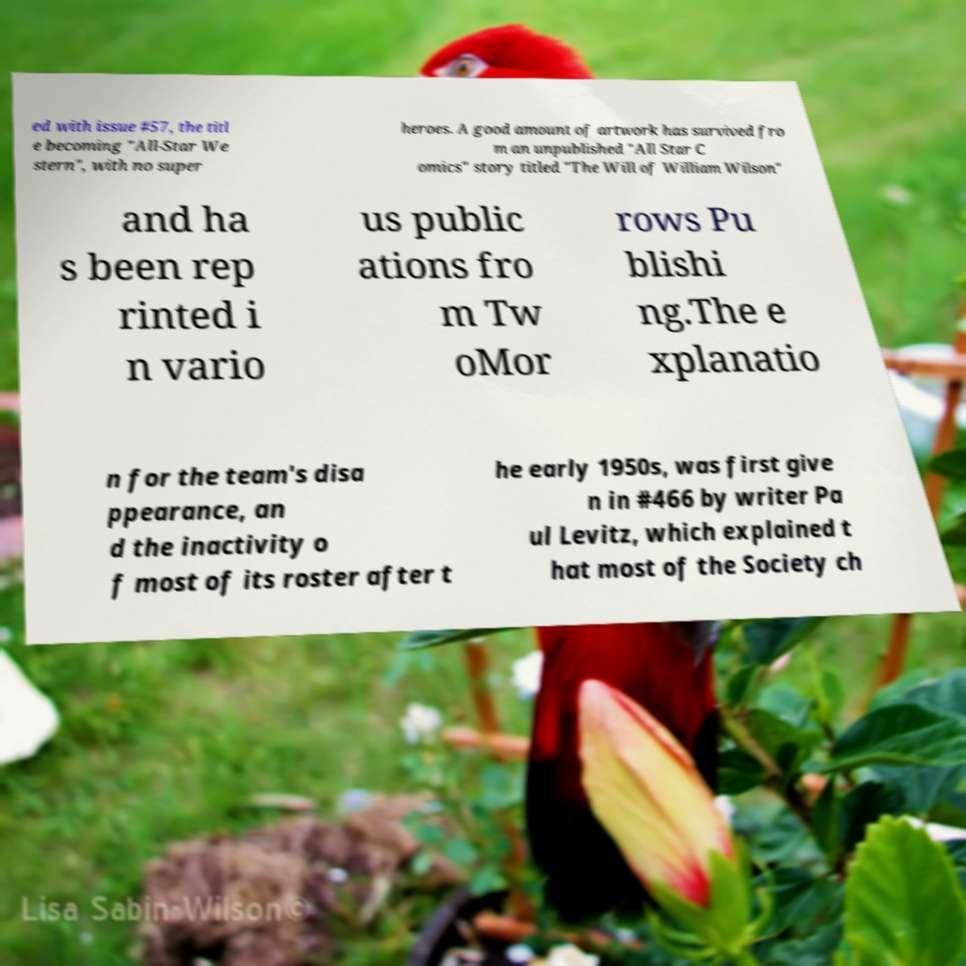There's text embedded in this image that I need extracted. Can you transcribe it verbatim? ed with issue #57, the titl e becoming "All-Star We stern", with no super heroes. A good amount of artwork has survived fro m an unpublished "All Star C omics" story titled "The Will of William Wilson" and ha s been rep rinted i n vario us public ations fro m Tw oMor rows Pu blishi ng.The e xplanatio n for the team's disa ppearance, an d the inactivity o f most of its roster after t he early 1950s, was first give n in #466 by writer Pa ul Levitz, which explained t hat most of the Society ch 